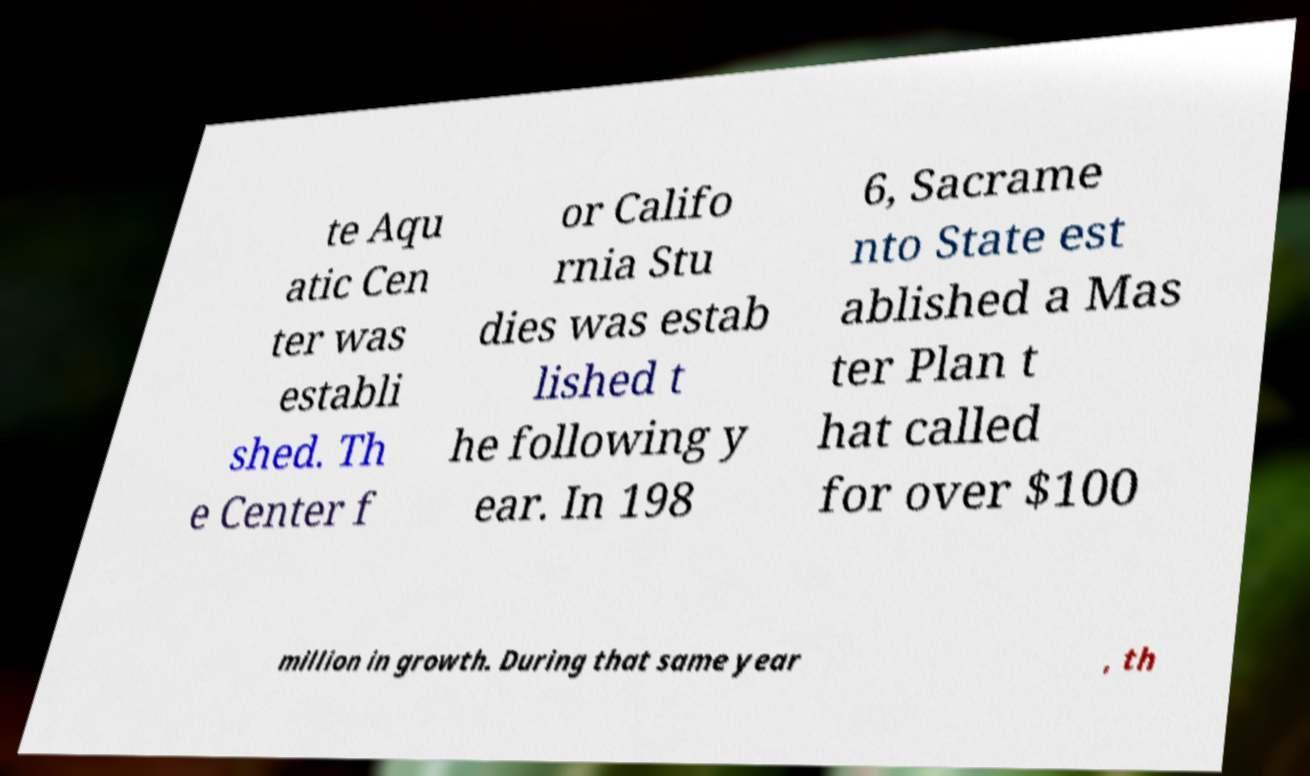Could you extract and type out the text from this image? te Aqu atic Cen ter was establi shed. Th e Center f or Califo rnia Stu dies was estab lished t he following y ear. In 198 6, Sacrame nto State est ablished a Mas ter Plan t hat called for over $100 million in growth. During that same year , th 